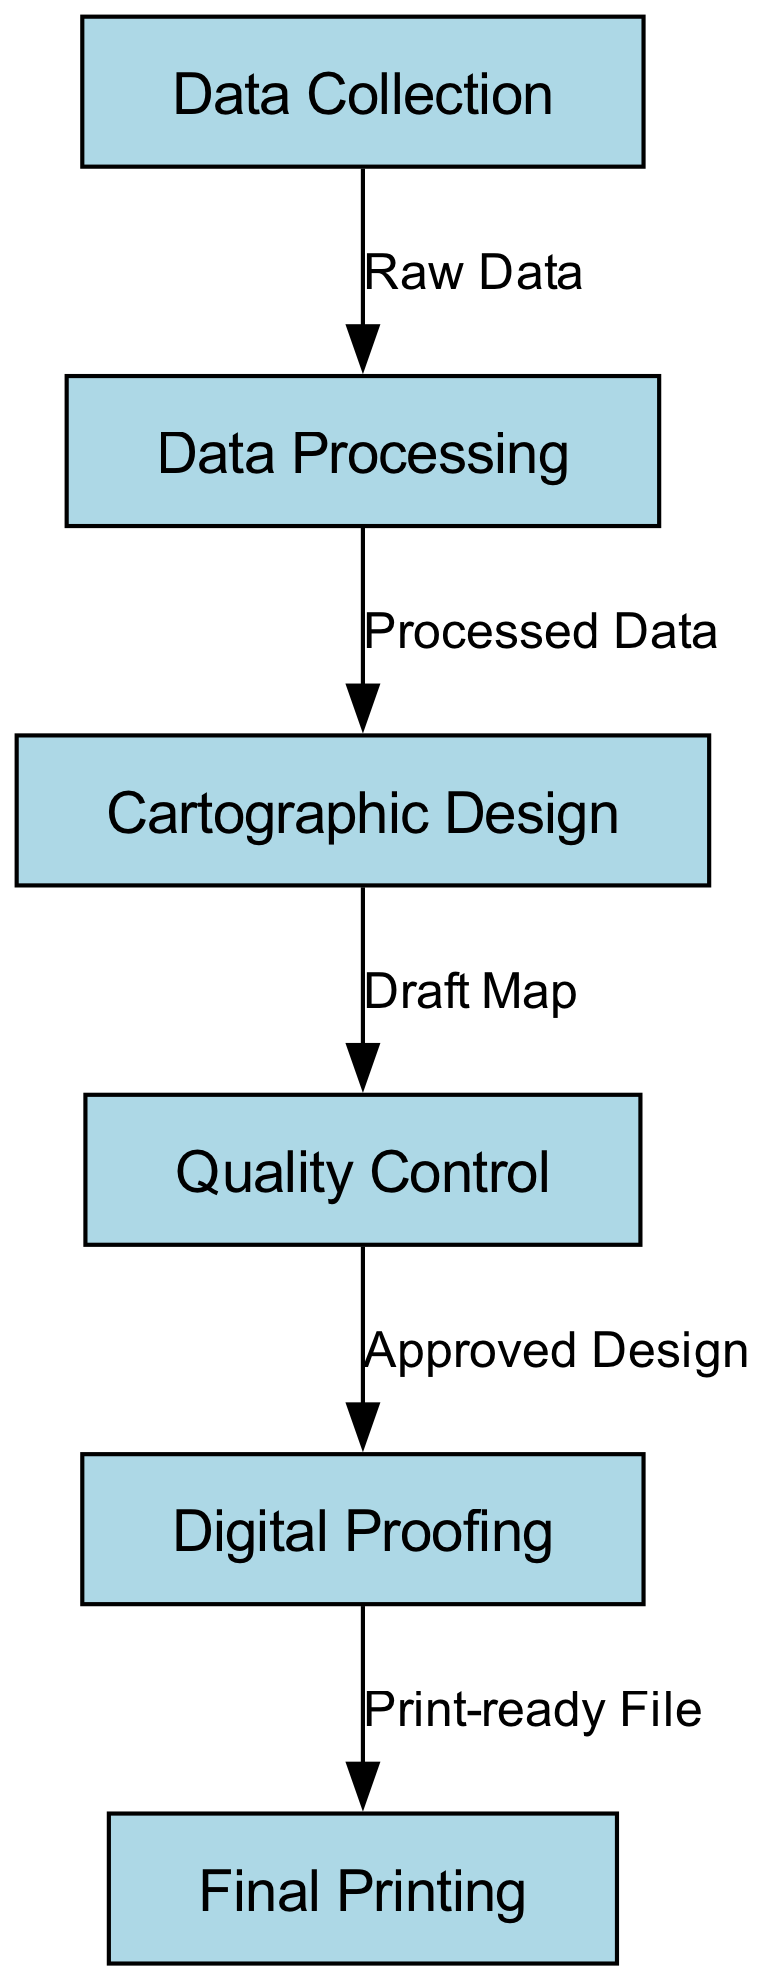What is the first step in the map creation process? The first step in the process outlined in the diagram is "Data Collection". This is determined by locating the initial node, which represents the beginning of the flowchart.
Answer: Data Collection How many nodes are present in the diagram? To find the number of nodes, I count all the distinct steps that are represented in the diagram. There are six nodes labeled from "Data Collection" to "Final Printing".
Answer: 6 What is the output of the "Data Processing" step? The output of the "Data Processing" step is labeled as "Processed Data". This can be seen on the edge that connects the "Data Processing" node to the next node.
Answer: Processed Data What follows the "Quality Control" step? The step that follows "Quality Control" in the diagram is "Digital Proofing". This is inferred by looking at the directed edge leading out of the "Quality Control" node.
Answer: Digital Proofing What is the final output after "Digital Proofing"? The final output after "Digital Proofing" is "Final Printing". This can be identified by the last edge in the flowchart connecting "Digital Proofing" to "Final Printing".
Answer: Final Printing How many edges are in the diagram? To determine the number of edges, I count the lines connecting the nodes. There are five edges in total, each one representing the transition between two steps.
Answer: 5 What is the relationship between "Cartographic Design" and "Quality Control"? The relationship between "Cartographic Design" and "Quality Control" can be described by the flow from "Cartographic Design", which outputs a "Draft Map", leading directly into "Quality Control" for approval.
Answer: Draft Map Which node is the penultimate step in the process? The penultimate step in the map creation process, just before the final output, is "Digital Proofing". This can be ascertained by observing the sequence of nodes leading to the last step.
Answer: Digital Proofing What is the transition between "Data Collection" and "Data Processing"? The transition between these two nodes is referred to as "Raw Data". This label is shown on the edge connecting them, indicating the output from the first step.
Answer: Raw Data 